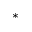Convert formula to latex. <formula><loc_0><loc_0><loc_500><loc_500>^ { * }</formula> 